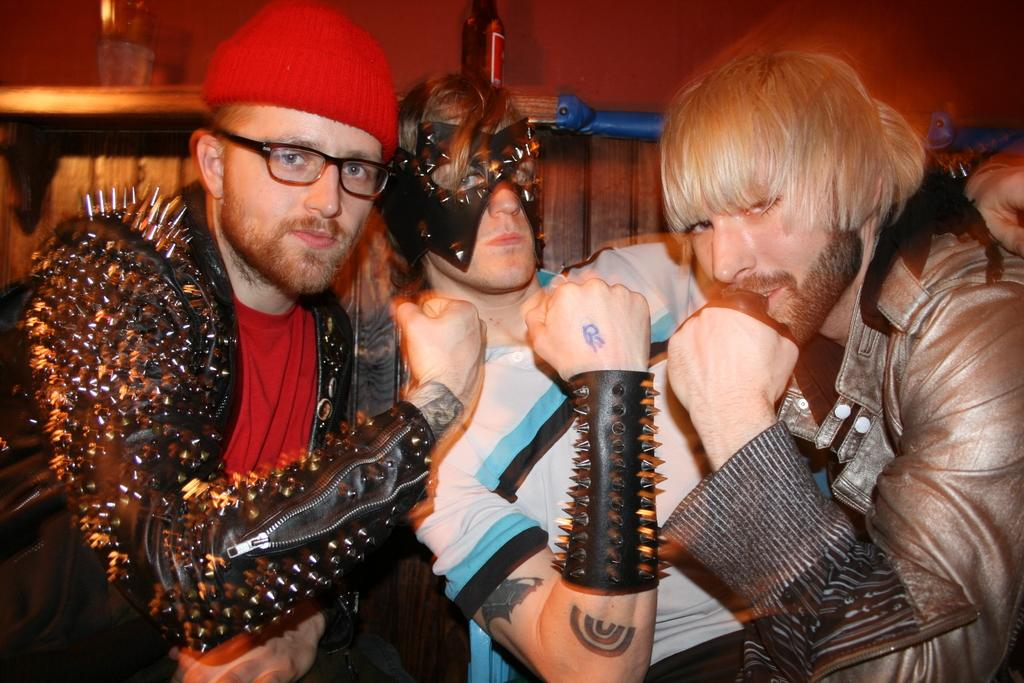What are the people in the image wearing? The people in the image are wearing different costumes. Can you describe the background of the image? There is a bottle and a wooden wall in the background of the image. What type of office can be seen in the background of the image? There is no office present in the background of the image; it features a wooden wall and a bottle. 